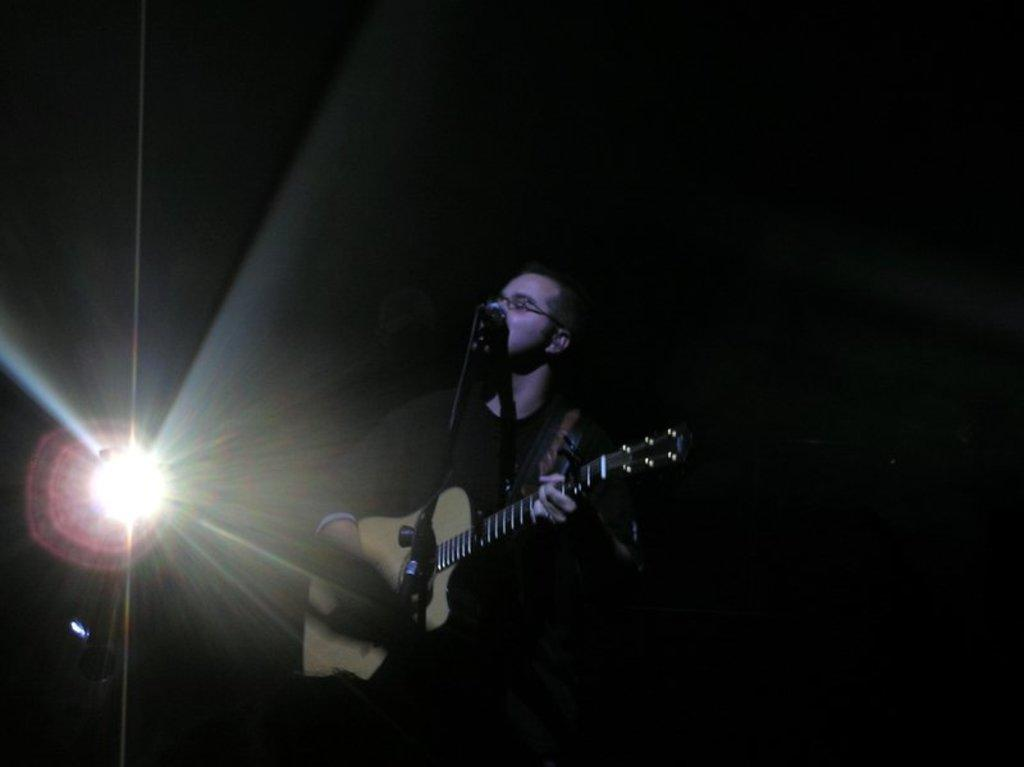What is the main subject of the image? There is a guy in the image. What is the guy doing in the image? The guy is standing in the image. What object is the guy holding in his hand? The guy is holding a guitar in his hand. What other object can be seen in the image? There is a microphone in the image. What structure is present in the image? There is a stand in the image. What can be seen in the background of the image? There is a light in the background of the image. What type of collar is the guy wearing in the image? There is no collar visible on the guy in the image. What type of neck is the guy displaying in the image? The guy's neck is not the focus of the image, and no specific type of neck can be determined. 